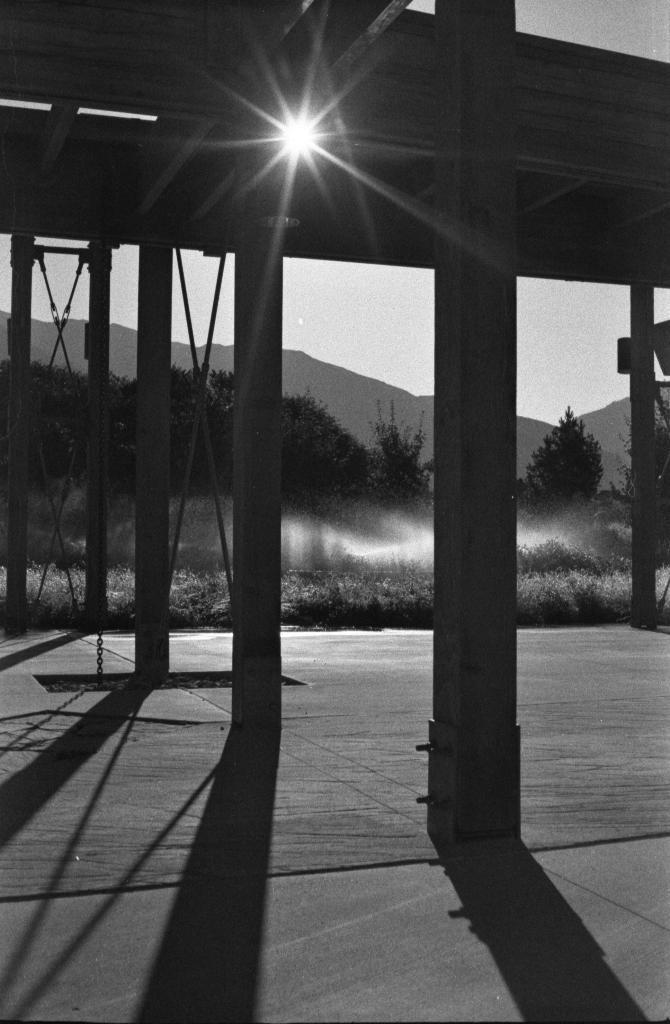What type of natural landscape is depicted in the image? The image features mountains and trees. What structure can be seen in the foreground of the image? There is a building in the foreground of the image. What is visible at the top of the image? The sky is visible at the top of the image, and there might be a sun in the sky. What is present at the bottom of the image? There is a floor at the bottom of the image. Can you tell me how many pins are stuck in the secretary's hat in the image? There is no secretary or hat present in the image; it features mountains, trees, a building, and a floor. 